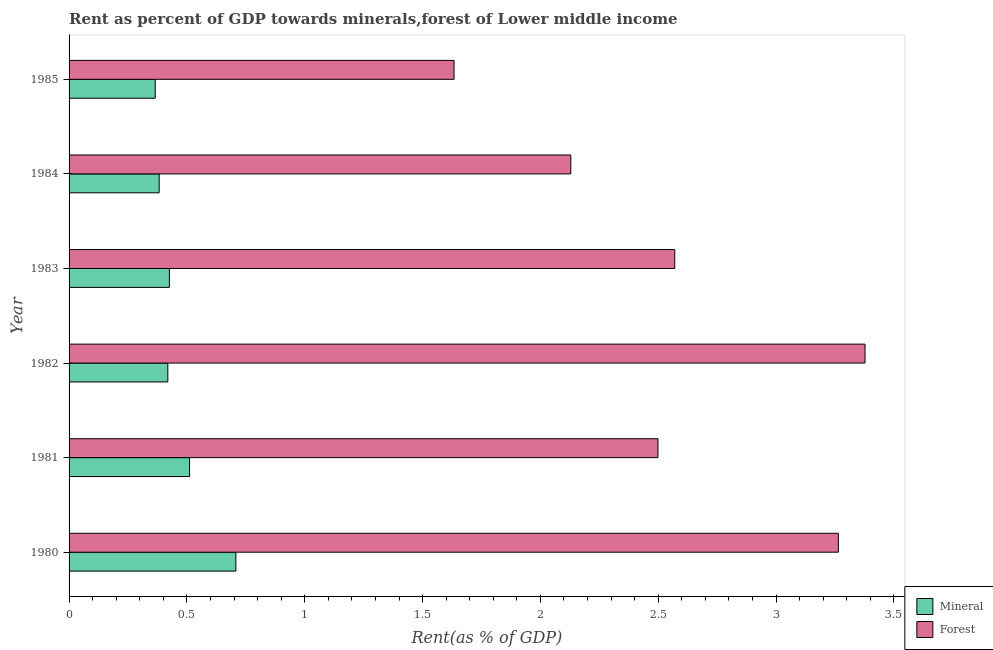How many different coloured bars are there?
Provide a short and direct response. 2. How many groups of bars are there?
Offer a terse response. 6. Are the number of bars per tick equal to the number of legend labels?
Offer a very short reply. Yes. How many bars are there on the 1st tick from the top?
Provide a succinct answer. 2. In how many cases, is the number of bars for a given year not equal to the number of legend labels?
Ensure brevity in your answer.  0. What is the forest rent in 1982?
Offer a terse response. 3.38. Across all years, what is the maximum forest rent?
Your response must be concise. 3.38. Across all years, what is the minimum forest rent?
Your answer should be very brief. 1.63. What is the total forest rent in the graph?
Your answer should be compact. 15.47. What is the difference between the forest rent in 1980 and that in 1983?
Ensure brevity in your answer.  0.69. What is the difference between the mineral rent in 1984 and the forest rent in 1981?
Provide a succinct answer. -2.12. What is the average forest rent per year?
Give a very brief answer. 2.58. In the year 1982, what is the difference between the forest rent and mineral rent?
Give a very brief answer. 2.96. In how many years, is the forest rent greater than 3.2 %?
Keep it short and to the point. 2. What is the ratio of the mineral rent in 1980 to that in 1985?
Keep it short and to the point. 1.94. What is the difference between the highest and the second highest forest rent?
Ensure brevity in your answer.  0.11. What is the difference between the highest and the lowest mineral rent?
Keep it short and to the point. 0.34. In how many years, is the mineral rent greater than the average mineral rent taken over all years?
Your answer should be very brief. 2. Is the sum of the mineral rent in 1984 and 1985 greater than the maximum forest rent across all years?
Give a very brief answer. No. What does the 1st bar from the top in 1981 represents?
Your response must be concise. Forest. What does the 1st bar from the bottom in 1980 represents?
Provide a short and direct response. Mineral. How many bars are there?
Your answer should be very brief. 12. How many years are there in the graph?
Your response must be concise. 6. What is the difference between two consecutive major ticks on the X-axis?
Offer a very short reply. 0.5. Where does the legend appear in the graph?
Provide a succinct answer. Bottom right. What is the title of the graph?
Provide a succinct answer. Rent as percent of GDP towards minerals,forest of Lower middle income. Does "Domestic liabilities" appear as one of the legend labels in the graph?
Ensure brevity in your answer.  No. What is the label or title of the X-axis?
Your answer should be very brief. Rent(as % of GDP). What is the label or title of the Y-axis?
Provide a succinct answer. Year. What is the Rent(as % of GDP) of Mineral in 1980?
Make the answer very short. 0.71. What is the Rent(as % of GDP) in Forest in 1980?
Give a very brief answer. 3.26. What is the Rent(as % of GDP) in Mineral in 1981?
Your answer should be compact. 0.51. What is the Rent(as % of GDP) in Forest in 1981?
Give a very brief answer. 2.5. What is the Rent(as % of GDP) of Mineral in 1982?
Give a very brief answer. 0.42. What is the Rent(as % of GDP) in Forest in 1982?
Give a very brief answer. 3.38. What is the Rent(as % of GDP) in Mineral in 1983?
Your answer should be very brief. 0.43. What is the Rent(as % of GDP) of Forest in 1983?
Offer a terse response. 2.57. What is the Rent(as % of GDP) in Mineral in 1984?
Your response must be concise. 0.38. What is the Rent(as % of GDP) in Forest in 1984?
Ensure brevity in your answer.  2.13. What is the Rent(as % of GDP) in Mineral in 1985?
Provide a succinct answer. 0.37. What is the Rent(as % of GDP) in Forest in 1985?
Make the answer very short. 1.63. Across all years, what is the maximum Rent(as % of GDP) in Mineral?
Your response must be concise. 0.71. Across all years, what is the maximum Rent(as % of GDP) in Forest?
Your answer should be very brief. 3.38. Across all years, what is the minimum Rent(as % of GDP) of Mineral?
Your response must be concise. 0.37. Across all years, what is the minimum Rent(as % of GDP) in Forest?
Provide a short and direct response. 1.63. What is the total Rent(as % of GDP) in Mineral in the graph?
Your response must be concise. 2.81. What is the total Rent(as % of GDP) of Forest in the graph?
Offer a terse response. 15.47. What is the difference between the Rent(as % of GDP) in Mineral in 1980 and that in 1981?
Your answer should be very brief. 0.2. What is the difference between the Rent(as % of GDP) of Forest in 1980 and that in 1981?
Offer a terse response. 0.77. What is the difference between the Rent(as % of GDP) in Mineral in 1980 and that in 1982?
Provide a short and direct response. 0.29. What is the difference between the Rent(as % of GDP) in Forest in 1980 and that in 1982?
Ensure brevity in your answer.  -0.11. What is the difference between the Rent(as % of GDP) in Mineral in 1980 and that in 1983?
Offer a terse response. 0.28. What is the difference between the Rent(as % of GDP) in Forest in 1980 and that in 1983?
Ensure brevity in your answer.  0.69. What is the difference between the Rent(as % of GDP) in Mineral in 1980 and that in 1984?
Provide a short and direct response. 0.33. What is the difference between the Rent(as % of GDP) of Forest in 1980 and that in 1984?
Give a very brief answer. 1.14. What is the difference between the Rent(as % of GDP) in Mineral in 1980 and that in 1985?
Provide a succinct answer. 0.34. What is the difference between the Rent(as % of GDP) in Forest in 1980 and that in 1985?
Ensure brevity in your answer.  1.63. What is the difference between the Rent(as % of GDP) in Mineral in 1981 and that in 1982?
Offer a very short reply. 0.09. What is the difference between the Rent(as % of GDP) in Forest in 1981 and that in 1982?
Your response must be concise. -0.88. What is the difference between the Rent(as % of GDP) of Mineral in 1981 and that in 1983?
Your answer should be compact. 0.09. What is the difference between the Rent(as % of GDP) of Forest in 1981 and that in 1983?
Offer a very short reply. -0.07. What is the difference between the Rent(as % of GDP) of Mineral in 1981 and that in 1984?
Keep it short and to the point. 0.13. What is the difference between the Rent(as % of GDP) in Forest in 1981 and that in 1984?
Keep it short and to the point. 0.37. What is the difference between the Rent(as % of GDP) of Mineral in 1981 and that in 1985?
Your response must be concise. 0.15. What is the difference between the Rent(as % of GDP) of Forest in 1981 and that in 1985?
Give a very brief answer. 0.87. What is the difference between the Rent(as % of GDP) of Mineral in 1982 and that in 1983?
Provide a succinct answer. -0.01. What is the difference between the Rent(as % of GDP) in Forest in 1982 and that in 1983?
Provide a short and direct response. 0.81. What is the difference between the Rent(as % of GDP) in Mineral in 1982 and that in 1984?
Keep it short and to the point. 0.04. What is the difference between the Rent(as % of GDP) of Forest in 1982 and that in 1984?
Give a very brief answer. 1.25. What is the difference between the Rent(as % of GDP) of Mineral in 1982 and that in 1985?
Provide a short and direct response. 0.05. What is the difference between the Rent(as % of GDP) in Forest in 1982 and that in 1985?
Your answer should be very brief. 1.74. What is the difference between the Rent(as % of GDP) of Mineral in 1983 and that in 1984?
Provide a succinct answer. 0.04. What is the difference between the Rent(as % of GDP) in Forest in 1983 and that in 1984?
Offer a terse response. 0.44. What is the difference between the Rent(as % of GDP) of Mineral in 1983 and that in 1985?
Make the answer very short. 0.06. What is the difference between the Rent(as % of GDP) of Forest in 1983 and that in 1985?
Make the answer very short. 0.94. What is the difference between the Rent(as % of GDP) of Mineral in 1984 and that in 1985?
Make the answer very short. 0.02. What is the difference between the Rent(as % of GDP) in Forest in 1984 and that in 1985?
Your response must be concise. 0.5. What is the difference between the Rent(as % of GDP) in Mineral in 1980 and the Rent(as % of GDP) in Forest in 1981?
Make the answer very short. -1.79. What is the difference between the Rent(as % of GDP) of Mineral in 1980 and the Rent(as % of GDP) of Forest in 1982?
Offer a very short reply. -2.67. What is the difference between the Rent(as % of GDP) of Mineral in 1980 and the Rent(as % of GDP) of Forest in 1983?
Give a very brief answer. -1.86. What is the difference between the Rent(as % of GDP) of Mineral in 1980 and the Rent(as % of GDP) of Forest in 1984?
Keep it short and to the point. -1.42. What is the difference between the Rent(as % of GDP) in Mineral in 1980 and the Rent(as % of GDP) in Forest in 1985?
Keep it short and to the point. -0.93. What is the difference between the Rent(as % of GDP) in Mineral in 1981 and the Rent(as % of GDP) in Forest in 1982?
Your answer should be very brief. -2.87. What is the difference between the Rent(as % of GDP) of Mineral in 1981 and the Rent(as % of GDP) of Forest in 1983?
Your response must be concise. -2.06. What is the difference between the Rent(as % of GDP) in Mineral in 1981 and the Rent(as % of GDP) in Forest in 1984?
Make the answer very short. -1.62. What is the difference between the Rent(as % of GDP) of Mineral in 1981 and the Rent(as % of GDP) of Forest in 1985?
Keep it short and to the point. -1.12. What is the difference between the Rent(as % of GDP) of Mineral in 1982 and the Rent(as % of GDP) of Forest in 1983?
Ensure brevity in your answer.  -2.15. What is the difference between the Rent(as % of GDP) of Mineral in 1982 and the Rent(as % of GDP) of Forest in 1984?
Keep it short and to the point. -1.71. What is the difference between the Rent(as % of GDP) in Mineral in 1982 and the Rent(as % of GDP) in Forest in 1985?
Offer a very short reply. -1.21. What is the difference between the Rent(as % of GDP) of Mineral in 1983 and the Rent(as % of GDP) of Forest in 1984?
Offer a terse response. -1.7. What is the difference between the Rent(as % of GDP) of Mineral in 1983 and the Rent(as % of GDP) of Forest in 1985?
Ensure brevity in your answer.  -1.21. What is the difference between the Rent(as % of GDP) in Mineral in 1984 and the Rent(as % of GDP) in Forest in 1985?
Keep it short and to the point. -1.25. What is the average Rent(as % of GDP) in Mineral per year?
Offer a very short reply. 0.47. What is the average Rent(as % of GDP) of Forest per year?
Make the answer very short. 2.58. In the year 1980, what is the difference between the Rent(as % of GDP) of Mineral and Rent(as % of GDP) of Forest?
Give a very brief answer. -2.56. In the year 1981, what is the difference between the Rent(as % of GDP) in Mineral and Rent(as % of GDP) in Forest?
Your answer should be compact. -1.99. In the year 1982, what is the difference between the Rent(as % of GDP) of Mineral and Rent(as % of GDP) of Forest?
Make the answer very short. -2.96. In the year 1983, what is the difference between the Rent(as % of GDP) of Mineral and Rent(as % of GDP) of Forest?
Provide a short and direct response. -2.14. In the year 1984, what is the difference between the Rent(as % of GDP) of Mineral and Rent(as % of GDP) of Forest?
Your answer should be very brief. -1.75. In the year 1985, what is the difference between the Rent(as % of GDP) of Mineral and Rent(as % of GDP) of Forest?
Provide a succinct answer. -1.27. What is the ratio of the Rent(as % of GDP) in Mineral in 1980 to that in 1981?
Provide a succinct answer. 1.38. What is the ratio of the Rent(as % of GDP) of Forest in 1980 to that in 1981?
Keep it short and to the point. 1.31. What is the ratio of the Rent(as % of GDP) of Mineral in 1980 to that in 1982?
Make the answer very short. 1.69. What is the ratio of the Rent(as % of GDP) in Forest in 1980 to that in 1982?
Keep it short and to the point. 0.97. What is the ratio of the Rent(as % of GDP) in Mineral in 1980 to that in 1983?
Provide a succinct answer. 1.66. What is the ratio of the Rent(as % of GDP) of Forest in 1980 to that in 1983?
Your answer should be compact. 1.27. What is the ratio of the Rent(as % of GDP) in Mineral in 1980 to that in 1984?
Your answer should be very brief. 1.85. What is the ratio of the Rent(as % of GDP) in Forest in 1980 to that in 1984?
Your answer should be compact. 1.53. What is the ratio of the Rent(as % of GDP) in Mineral in 1980 to that in 1985?
Make the answer very short. 1.94. What is the ratio of the Rent(as % of GDP) of Forest in 1980 to that in 1985?
Your answer should be compact. 2. What is the ratio of the Rent(as % of GDP) in Mineral in 1981 to that in 1982?
Make the answer very short. 1.22. What is the ratio of the Rent(as % of GDP) of Forest in 1981 to that in 1982?
Provide a short and direct response. 0.74. What is the ratio of the Rent(as % of GDP) of Mineral in 1981 to that in 1983?
Make the answer very short. 1.2. What is the ratio of the Rent(as % of GDP) in Forest in 1981 to that in 1983?
Give a very brief answer. 0.97. What is the ratio of the Rent(as % of GDP) of Mineral in 1981 to that in 1984?
Your response must be concise. 1.34. What is the ratio of the Rent(as % of GDP) in Forest in 1981 to that in 1984?
Ensure brevity in your answer.  1.17. What is the ratio of the Rent(as % of GDP) in Mineral in 1981 to that in 1985?
Make the answer very short. 1.4. What is the ratio of the Rent(as % of GDP) in Forest in 1981 to that in 1985?
Your answer should be very brief. 1.53. What is the ratio of the Rent(as % of GDP) in Mineral in 1982 to that in 1983?
Your response must be concise. 0.98. What is the ratio of the Rent(as % of GDP) of Forest in 1982 to that in 1983?
Provide a short and direct response. 1.31. What is the ratio of the Rent(as % of GDP) of Mineral in 1982 to that in 1984?
Offer a terse response. 1.1. What is the ratio of the Rent(as % of GDP) of Forest in 1982 to that in 1984?
Give a very brief answer. 1.59. What is the ratio of the Rent(as % of GDP) of Mineral in 1982 to that in 1985?
Provide a succinct answer. 1.15. What is the ratio of the Rent(as % of GDP) in Forest in 1982 to that in 1985?
Offer a very short reply. 2.07. What is the ratio of the Rent(as % of GDP) in Mineral in 1983 to that in 1984?
Offer a very short reply. 1.11. What is the ratio of the Rent(as % of GDP) of Forest in 1983 to that in 1984?
Your answer should be very brief. 1.21. What is the ratio of the Rent(as % of GDP) in Mineral in 1983 to that in 1985?
Your answer should be compact. 1.16. What is the ratio of the Rent(as % of GDP) of Forest in 1983 to that in 1985?
Your answer should be compact. 1.57. What is the ratio of the Rent(as % of GDP) in Mineral in 1984 to that in 1985?
Offer a terse response. 1.05. What is the ratio of the Rent(as % of GDP) of Forest in 1984 to that in 1985?
Ensure brevity in your answer.  1.3. What is the difference between the highest and the second highest Rent(as % of GDP) in Mineral?
Provide a short and direct response. 0.2. What is the difference between the highest and the second highest Rent(as % of GDP) of Forest?
Your response must be concise. 0.11. What is the difference between the highest and the lowest Rent(as % of GDP) of Mineral?
Provide a short and direct response. 0.34. What is the difference between the highest and the lowest Rent(as % of GDP) in Forest?
Your answer should be compact. 1.74. 